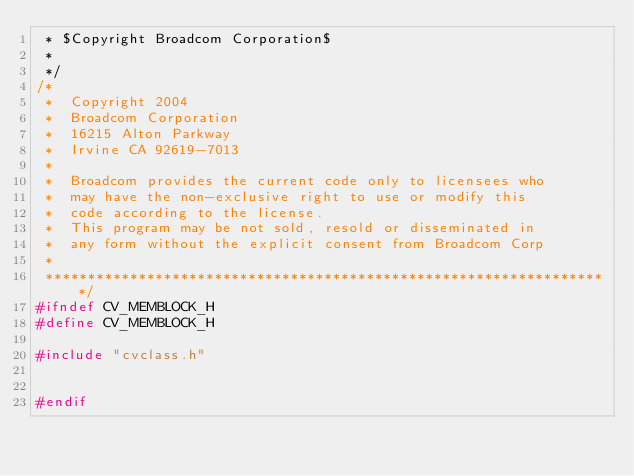<code> <loc_0><loc_0><loc_500><loc_500><_C_> * $Copyright Broadcom Corporation$
 *
 */
/*
 *  Copyright 2004
 *  Broadcom Corporation
 *  16215 Alton Parkway
 *  Irvine CA 92619-7013
 *
 *  Broadcom provides the current code only to licensees who
 *  may have the non-exclusive right to use or modify this
 *  code according to the license.
 *  This program may be not sold, resold or disseminated in
 *  any form without the explicit consent from Broadcom Corp
 *
 *******************************************************************/
#ifndef CV_MEMBLOCK_H
#define CV_MEMBLOCK_H

#include "cvclass.h"


#endif
</code> 